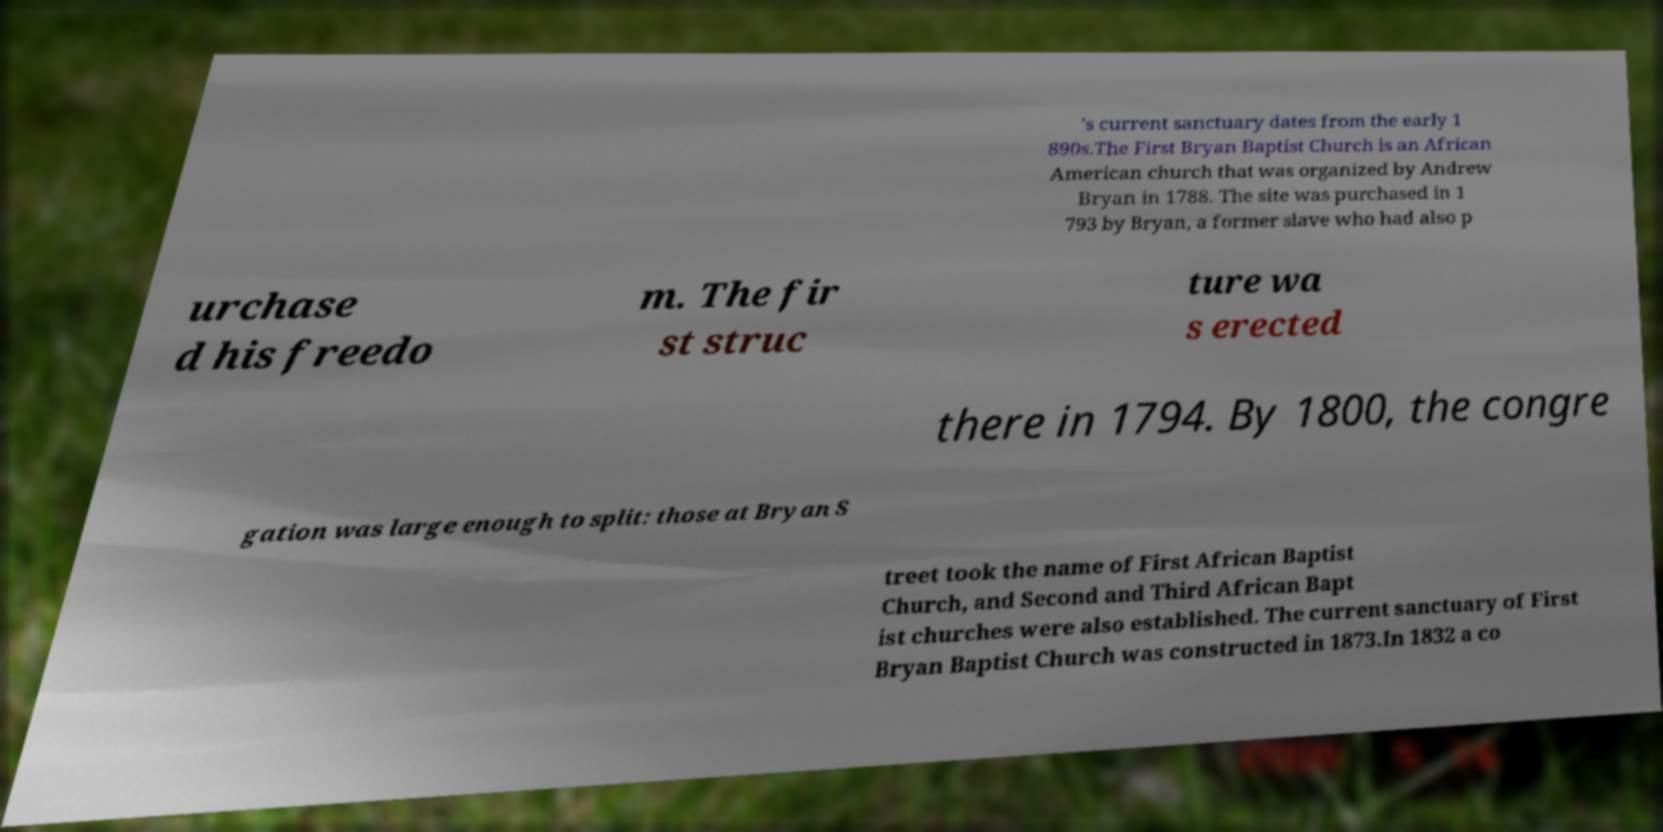I need the written content from this picture converted into text. Can you do that? 's current sanctuary dates from the early 1 890s.The First Bryan Baptist Church is an African American church that was organized by Andrew Bryan in 1788. The site was purchased in 1 793 by Bryan, a former slave who had also p urchase d his freedo m. The fir st struc ture wa s erected there in 1794. By 1800, the congre gation was large enough to split: those at Bryan S treet took the name of First African Baptist Church, and Second and Third African Bapt ist churches were also established. The current sanctuary of First Bryan Baptist Church was constructed in 1873.In 1832 a co 